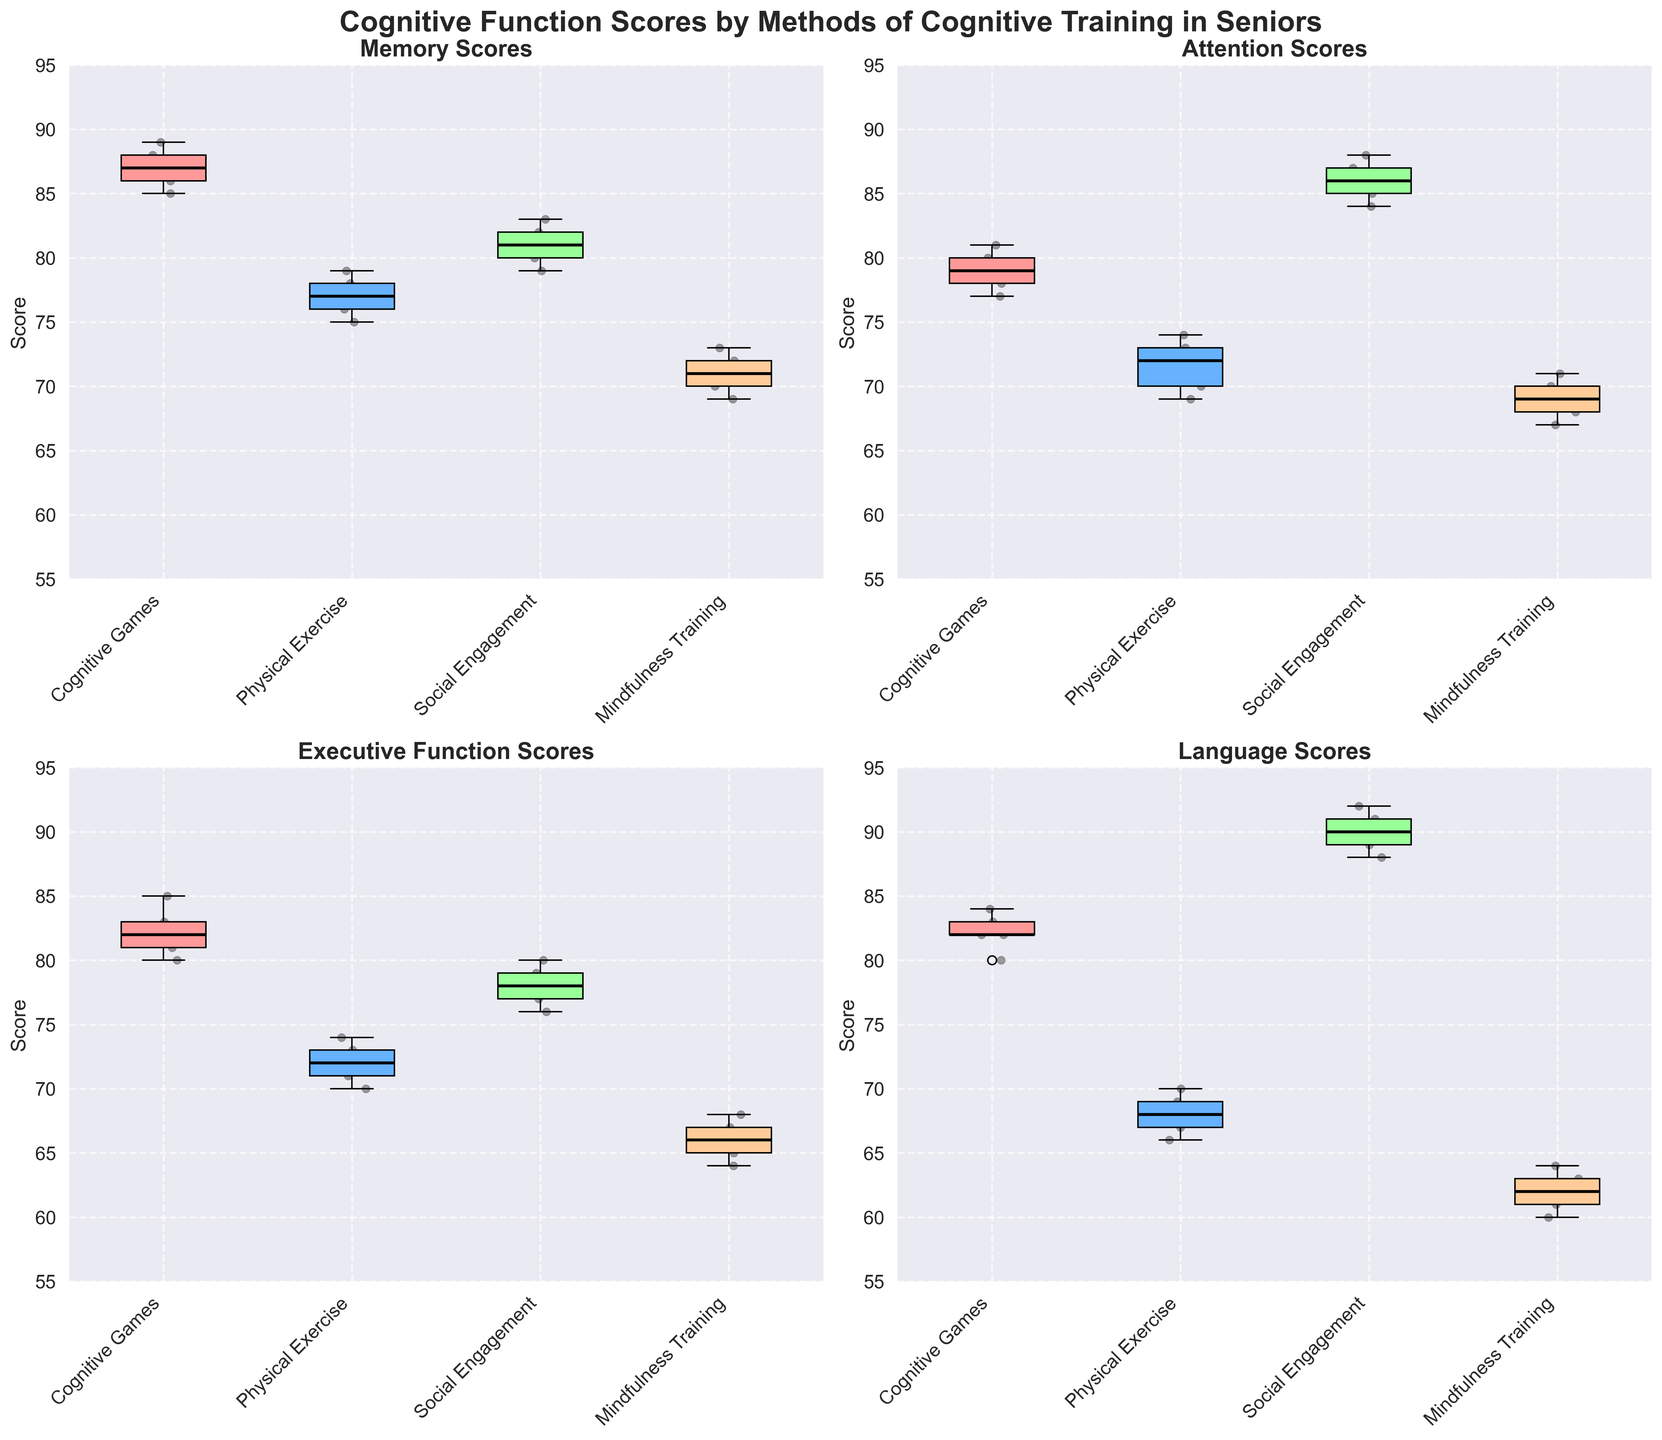What is the title of the figure? The title is usually located at the top of the figure, highlighting the main purpose of the plot.
Answer: 'Cognitive Function Scores by Methods of Cognitive Training in Seniors' Which group has the highest median Memory Scores? By examining the boxplot for Memory Scores, the median value is represented by the central line in each box.
Answer: Cognitive Games What are the types of cognitive scores displayed in the figure? The titles of each subplot indicate the types of cognitive scores being evaluated.
Answer: Memory Scores, Attention Scores, Executive Function Scores, Language Scores How do the median Attention Scores compare between Physical Exercise and Social Engagement? Look at the central line in each box for the Attention Scores subplot. Compare the height of these lines for the two groups.
Answer: Social Engagement has higher median Attention Scores than Physical Exercise What is the range of Language Scores for Mindfulness Training? To find the range, subtract the minimum value (bottom whisker) from the maximum value (top whisker) in the Language Scores subplot for Mindfulness Training.
Answer: 62 to 64, so the range is 2 Which group shows the most variability in Executive Function Scores? Variability is indicated by the interquartile range (IQR), which is the height of the box in each boxplot. Look for the highest box in the Executive Function Scores subplot.
Answer: Cognitive Games On which cognitive score does Social Engagement have the lowest median value? By checking the median lines in each boxplot for Social Engagement, identify the subplot with the lowest median line.
Answer: Executive Function Scores Is there any cognitive score where all groups have similar medians? Examine the median lines across all groups for each subplot to identify the score where medians are closest.
Answer: No, the groups show different medians for each cognitive score How do the Memory Scores of Physical Exercise compare to those of Mindfulness Training? Compare the boxplots for Memory Scores by observing the position of the boxes and their central lines.
Answer: Physical Exercise has higher Memory Scores than Mindfulness Training 